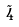Convert formula to latex. <formula><loc_0><loc_0><loc_500><loc_500>\tilde { 4 }</formula> 